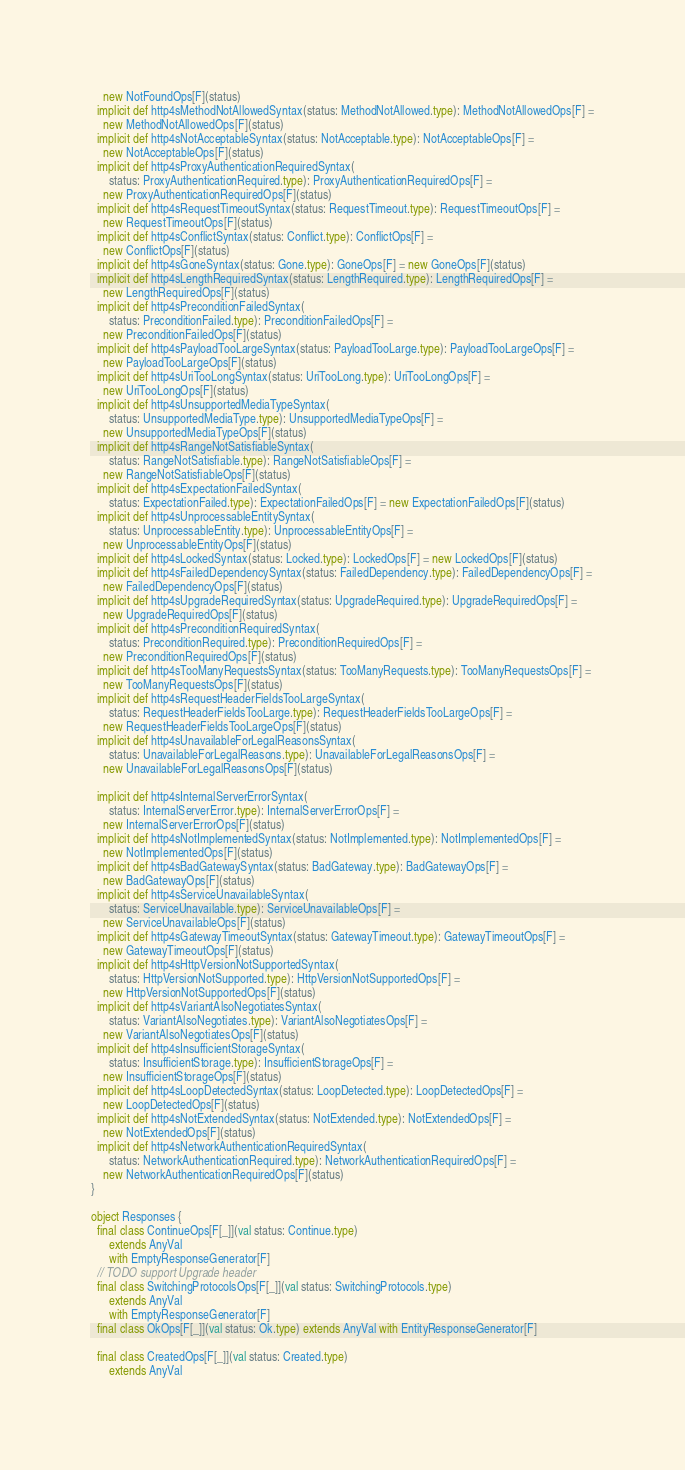<code> <loc_0><loc_0><loc_500><loc_500><_Scala_>    new NotFoundOps[F](status)
  implicit def http4sMethodNotAllowedSyntax(status: MethodNotAllowed.type): MethodNotAllowedOps[F] =
    new MethodNotAllowedOps[F](status)
  implicit def http4sNotAcceptableSyntax(status: NotAcceptable.type): NotAcceptableOps[F] =
    new NotAcceptableOps[F](status)
  implicit def http4sProxyAuthenticationRequiredSyntax(
      status: ProxyAuthenticationRequired.type): ProxyAuthenticationRequiredOps[F] =
    new ProxyAuthenticationRequiredOps[F](status)
  implicit def http4sRequestTimeoutSyntax(status: RequestTimeout.type): RequestTimeoutOps[F] =
    new RequestTimeoutOps[F](status)
  implicit def http4sConflictSyntax(status: Conflict.type): ConflictOps[F] =
    new ConflictOps[F](status)
  implicit def http4sGoneSyntax(status: Gone.type): GoneOps[F] = new GoneOps[F](status)
  implicit def http4sLengthRequiredSyntax(status: LengthRequired.type): LengthRequiredOps[F] =
    new LengthRequiredOps[F](status)
  implicit def http4sPreconditionFailedSyntax(
      status: PreconditionFailed.type): PreconditionFailedOps[F] =
    new PreconditionFailedOps[F](status)
  implicit def http4sPayloadTooLargeSyntax(status: PayloadTooLarge.type): PayloadTooLargeOps[F] =
    new PayloadTooLargeOps[F](status)
  implicit def http4sUriTooLongSyntax(status: UriTooLong.type): UriTooLongOps[F] =
    new UriTooLongOps[F](status)
  implicit def http4sUnsupportedMediaTypeSyntax(
      status: UnsupportedMediaType.type): UnsupportedMediaTypeOps[F] =
    new UnsupportedMediaTypeOps[F](status)
  implicit def http4sRangeNotSatisfiableSyntax(
      status: RangeNotSatisfiable.type): RangeNotSatisfiableOps[F] =
    new RangeNotSatisfiableOps[F](status)
  implicit def http4sExpectationFailedSyntax(
      status: ExpectationFailed.type): ExpectationFailedOps[F] = new ExpectationFailedOps[F](status)
  implicit def http4sUnprocessableEntitySyntax(
      status: UnprocessableEntity.type): UnprocessableEntityOps[F] =
    new UnprocessableEntityOps[F](status)
  implicit def http4sLockedSyntax(status: Locked.type): LockedOps[F] = new LockedOps[F](status)
  implicit def http4sFailedDependencySyntax(status: FailedDependency.type): FailedDependencyOps[F] =
    new FailedDependencyOps[F](status)
  implicit def http4sUpgradeRequiredSyntax(status: UpgradeRequired.type): UpgradeRequiredOps[F] =
    new UpgradeRequiredOps[F](status)
  implicit def http4sPreconditionRequiredSyntax(
      status: PreconditionRequired.type): PreconditionRequiredOps[F] =
    new PreconditionRequiredOps[F](status)
  implicit def http4sTooManyRequestsSyntax(status: TooManyRequests.type): TooManyRequestsOps[F] =
    new TooManyRequestsOps[F](status)
  implicit def http4sRequestHeaderFieldsTooLargeSyntax(
      status: RequestHeaderFieldsTooLarge.type): RequestHeaderFieldsTooLargeOps[F] =
    new RequestHeaderFieldsTooLargeOps[F](status)
  implicit def http4sUnavailableForLegalReasonsSyntax(
      status: UnavailableForLegalReasons.type): UnavailableForLegalReasonsOps[F] =
    new UnavailableForLegalReasonsOps[F](status)

  implicit def http4sInternalServerErrorSyntax(
      status: InternalServerError.type): InternalServerErrorOps[F] =
    new InternalServerErrorOps[F](status)
  implicit def http4sNotImplementedSyntax(status: NotImplemented.type): NotImplementedOps[F] =
    new NotImplementedOps[F](status)
  implicit def http4sBadGatewaySyntax(status: BadGateway.type): BadGatewayOps[F] =
    new BadGatewayOps[F](status)
  implicit def http4sServiceUnavailableSyntax(
      status: ServiceUnavailable.type): ServiceUnavailableOps[F] =
    new ServiceUnavailableOps[F](status)
  implicit def http4sGatewayTimeoutSyntax(status: GatewayTimeout.type): GatewayTimeoutOps[F] =
    new GatewayTimeoutOps[F](status)
  implicit def http4sHttpVersionNotSupportedSyntax(
      status: HttpVersionNotSupported.type): HttpVersionNotSupportedOps[F] =
    new HttpVersionNotSupportedOps[F](status)
  implicit def http4sVariantAlsoNegotiatesSyntax(
      status: VariantAlsoNegotiates.type): VariantAlsoNegotiatesOps[F] =
    new VariantAlsoNegotiatesOps[F](status)
  implicit def http4sInsufficientStorageSyntax(
      status: InsufficientStorage.type): InsufficientStorageOps[F] =
    new InsufficientStorageOps[F](status)
  implicit def http4sLoopDetectedSyntax(status: LoopDetected.type): LoopDetectedOps[F] =
    new LoopDetectedOps[F](status)
  implicit def http4sNotExtendedSyntax(status: NotExtended.type): NotExtendedOps[F] =
    new NotExtendedOps[F](status)
  implicit def http4sNetworkAuthenticationRequiredSyntax(
      status: NetworkAuthenticationRequired.type): NetworkAuthenticationRequiredOps[F] =
    new NetworkAuthenticationRequiredOps[F](status)
}

object Responses {
  final class ContinueOps[F[_]](val status: Continue.type)
      extends AnyVal
      with EmptyResponseGenerator[F]
  // TODO support Upgrade header
  final class SwitchingProtocolsOps[F[_]](val status: SwitchingProtocols.type)
      extends AnyVal
      with EmptyResponseGenerator[F]
  final class OkOps[F[_]](val status: Ok.type) extends AnyVal with EntityResponseGenerator[F]

  final class CreatedOps[F[_]](val status: Created.type)
      extends AnyVal</code> 